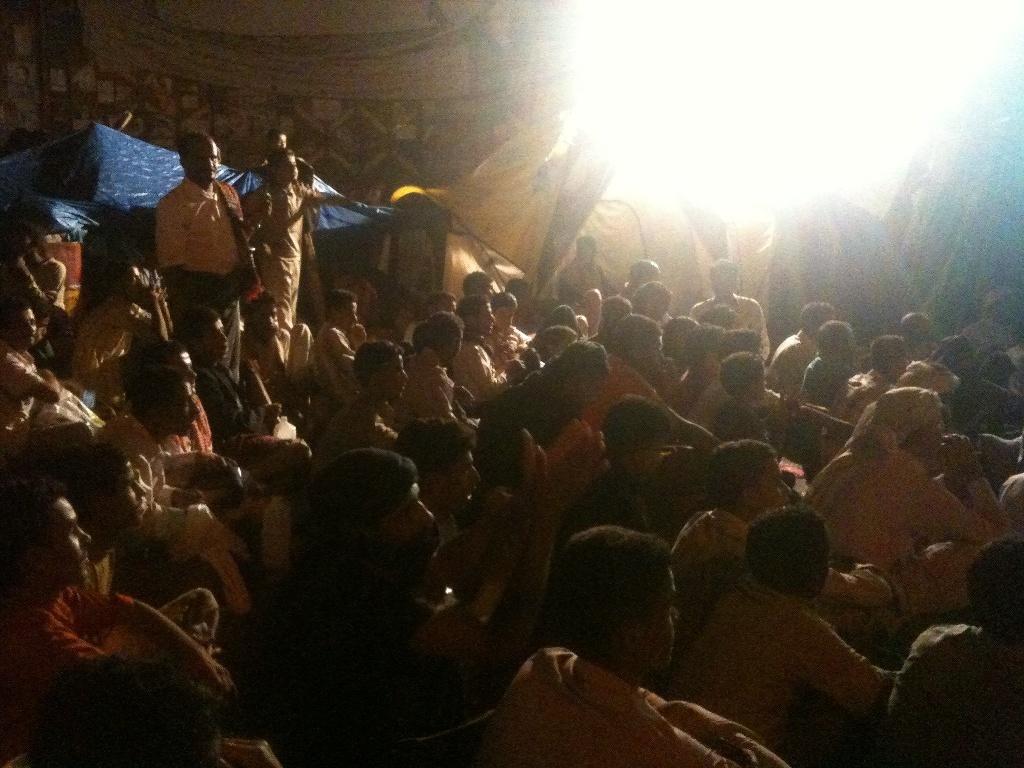Can you describe this image briefly? This picture seems to be clicked outside. In the foreground we can see the group of persons seems to be sitting on the ground and we can see the group of persons standing. In the background we can see the light, a blue color tint and some curtains and some other objects. 